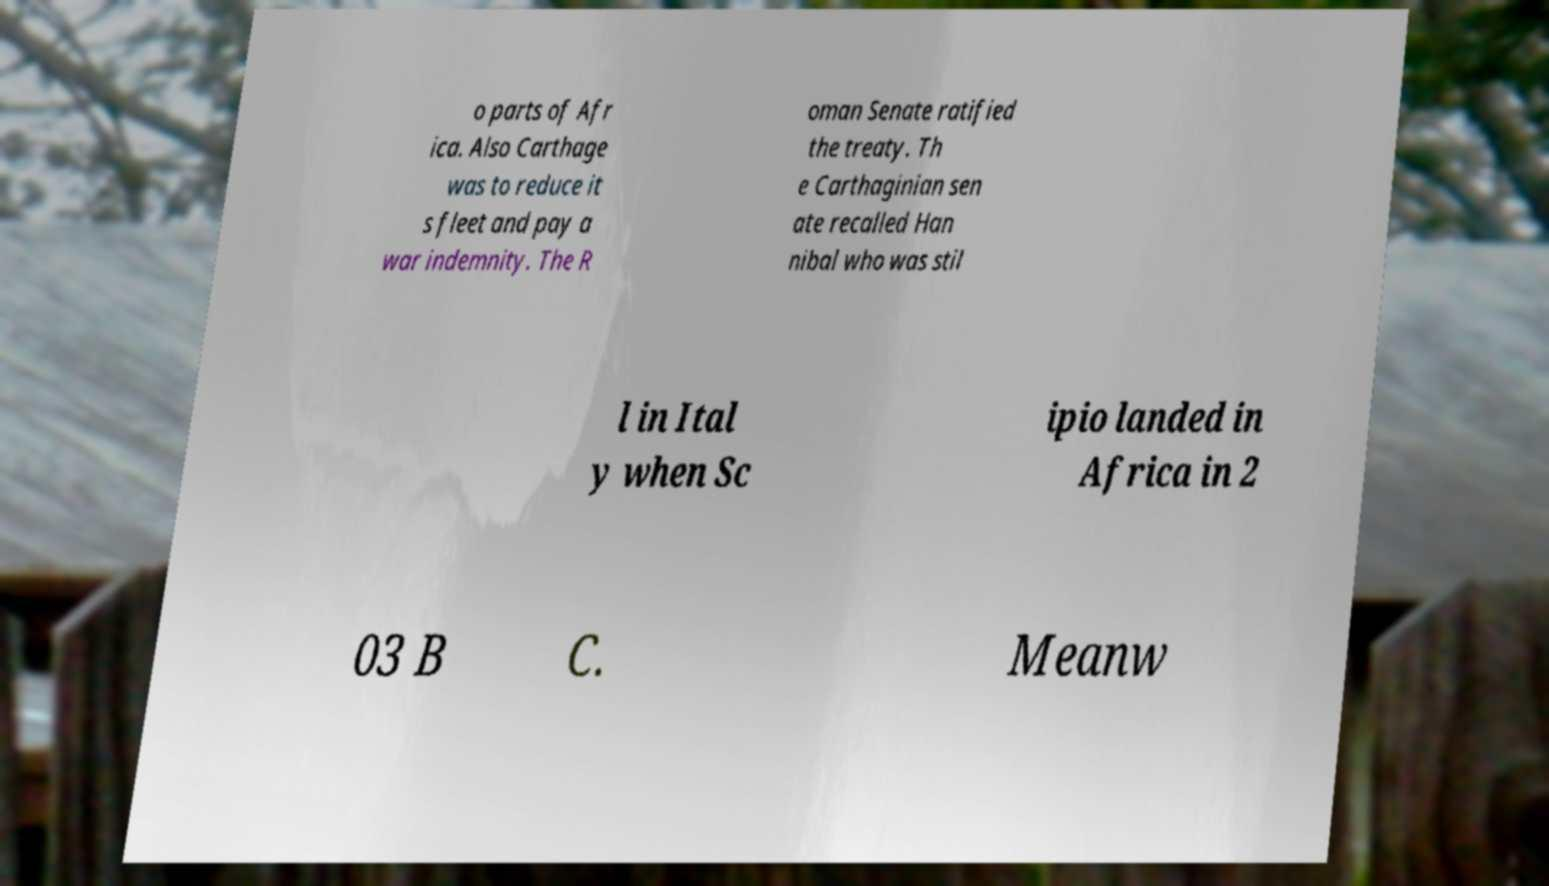Can you read and provide the text displayed in the image?This photo seems to have some interesting text. Can you extract and type it out for me? o parts of Afr ica. Also Carthage was to reduce it s fleet and pay a war indemnity. The R oman Senate ratified the treaty. Th e Carthaginian sen ate recalled Han nibal who was stil l in Ital y when Sc ipio landed in Africa in 2 03 B C. Meanw 